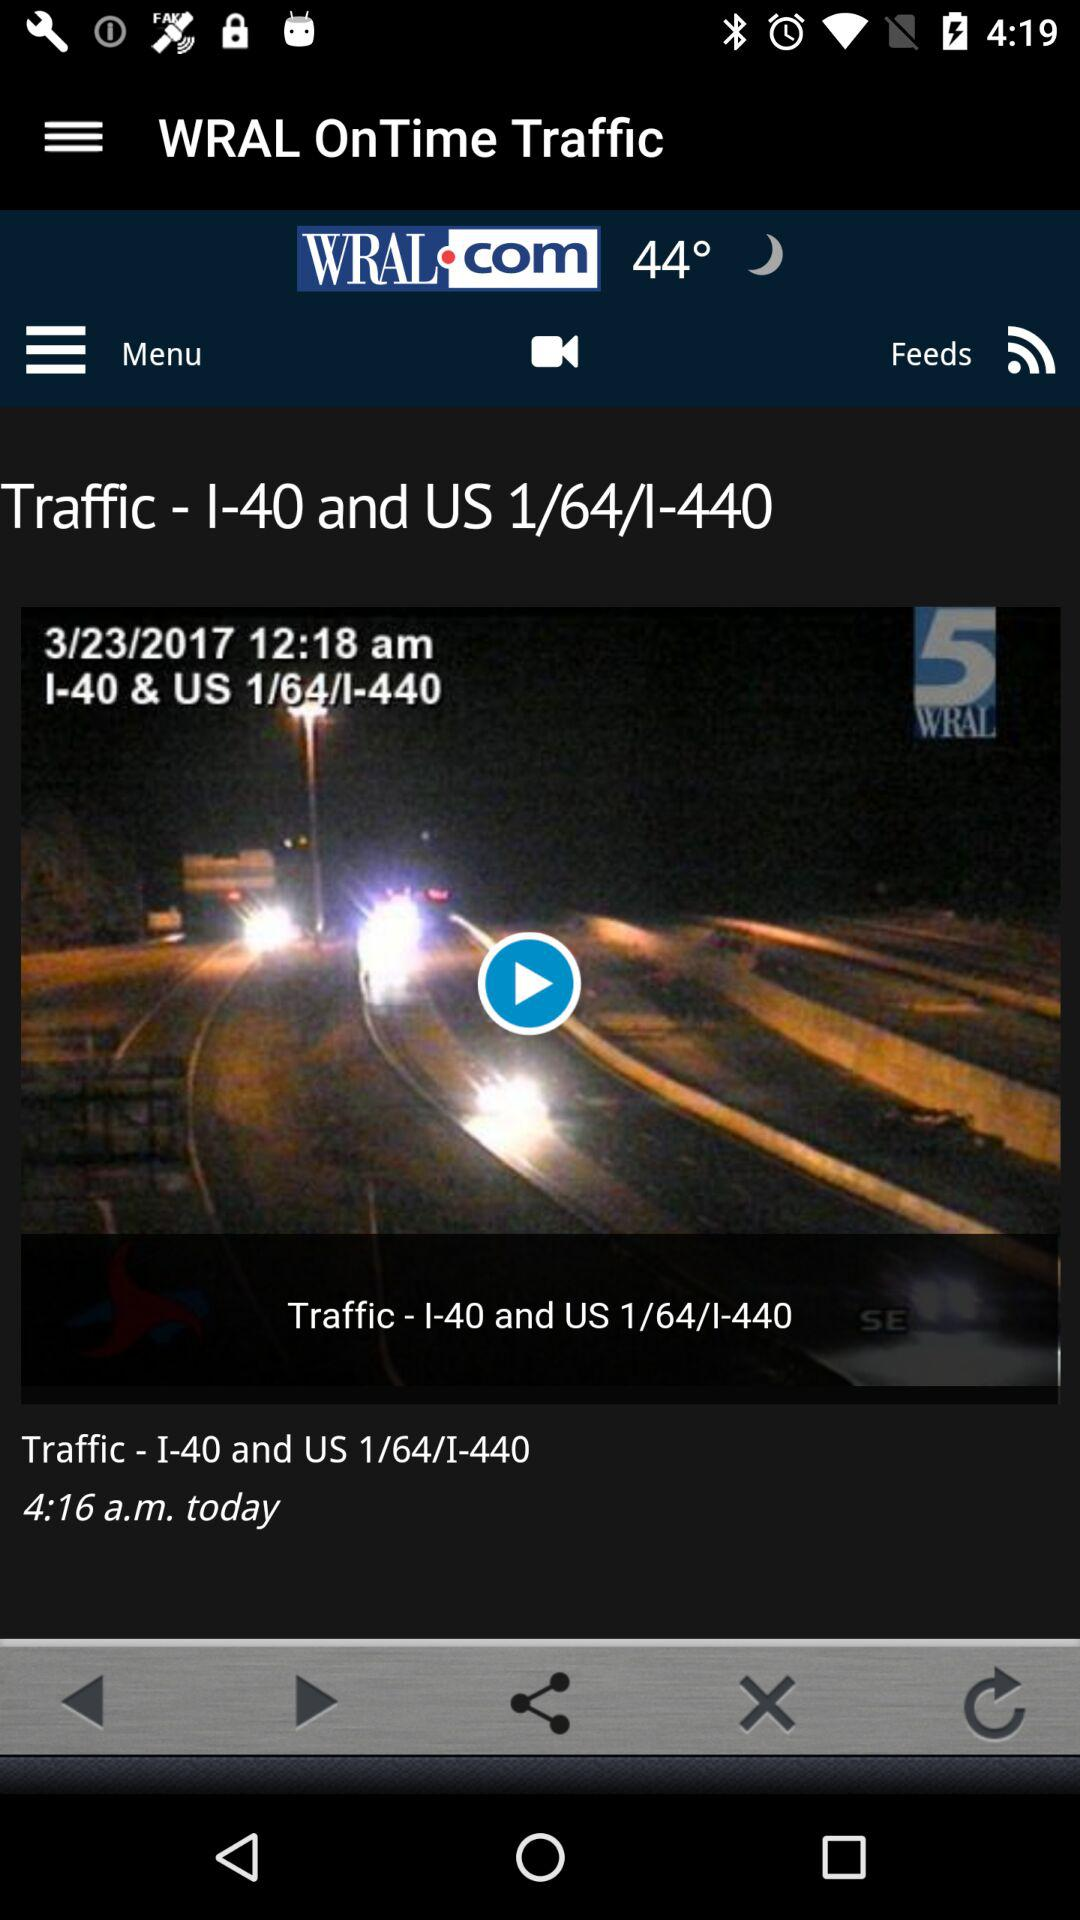At what time was the news posted? The news was posted at 4:16 a.m. 